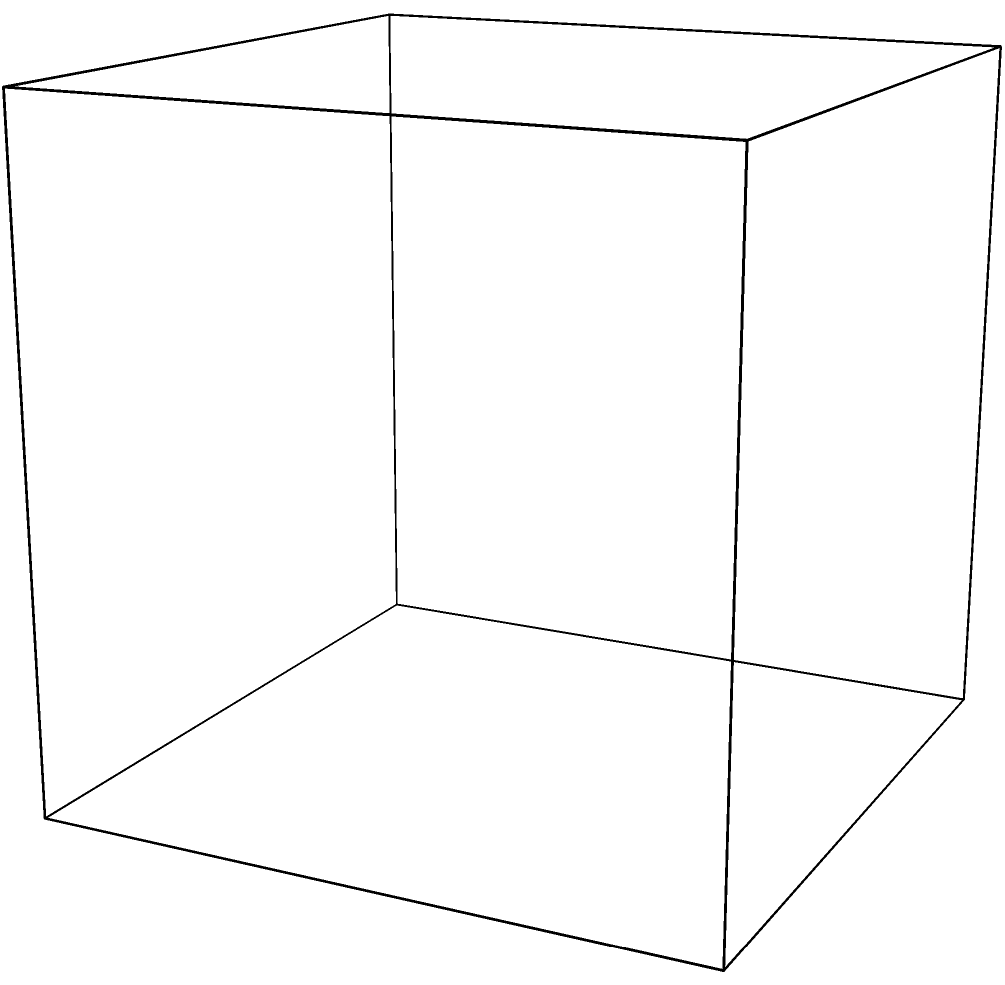In the design of a 3D-printed prosthetic limb, two planes (A and B) intersect at an angle $\theta$. If the normal vector to Plane A is $\vec{n_A} = (0, 0, 1)$ and the normal vector to Plane B is $\vec{n_B} = (0.5, 0.5, \sqrt{0.5})$, what is the angle $\theta$ between these planes in degrees? To find the angle between two planes, we can use the dot product of their normal vectors. The formula for the angle between two planes is:

$$\theta = \arccos\left(\frac{|\vec{n_A} \cdot \vec{n_B}|}{|\vec{n_A}||\vec{n_B}|}\right)$$

Step 1: Calculate the dot product of the normal vectors.
$\vec{n_A} \cdot \vec{n_B} = (0)(0.5) + (0)(0.5) + (1)(\sqrt{0.5}) = \sqrt{0.5}$

Step 2: Calculate the magnitudes of the normal vectors.
$|\vec{n_A}| = \sqrt{0^2 + 0^2 + 1^2} = 1$
$|\vec{n_B}| = \sqrt{0.5^2 + 0.5^2 + 0.5} = 1$

Step 3: Substitute into the formula.
$$\theta = \arccos\left(\frac{|\sqrt{0.5}|}{(1)(1)}\right) = \arccos(\sqrt{0.5})$$

Step 4: Calculate the result.
$\theta = \arccos(\sqrt{0.5}) \approx 0.7853981634$ radians

Step 5: Convert to degrees.
$\theta = 0.7853981634 \times \frac{180}{\pi} \approx 45°$
Answer: 45° 